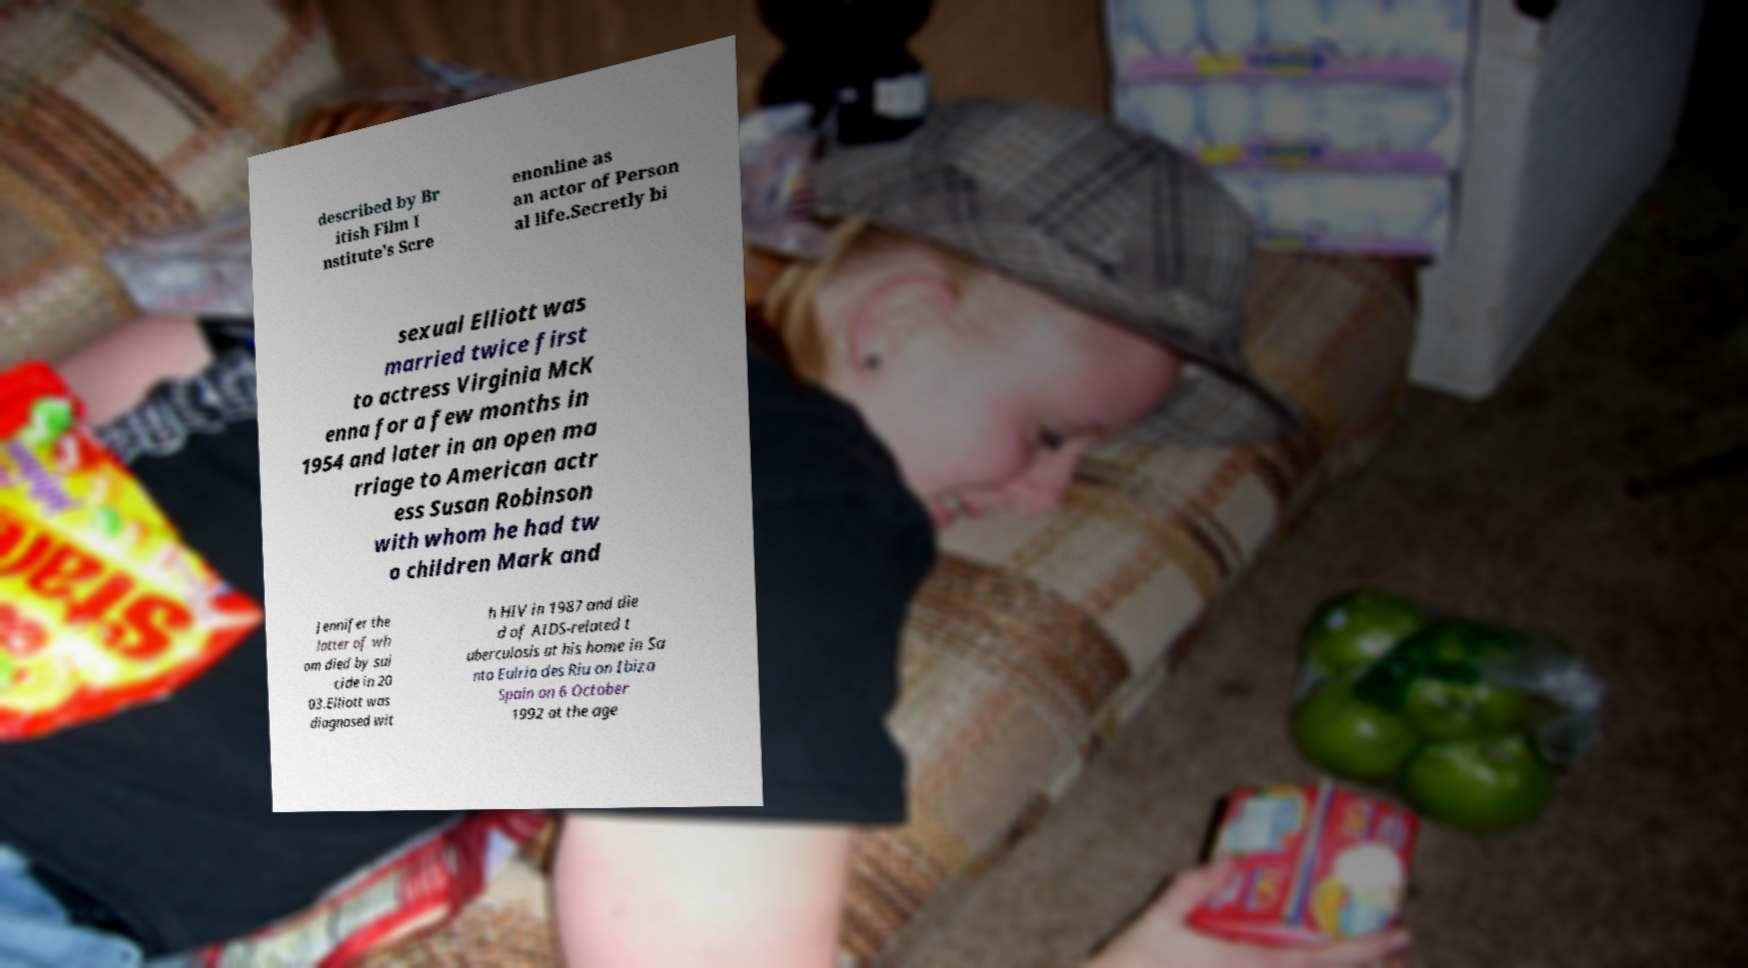Can you accurately transcribe the text from the provided image for me? described by Br itish Film I nstitute's Scre enonline as an actor of Person al life.Secretly bi sexual Elliott was married twice first to actress Virginia McK enna for a few months in 1954 and later in an open ma rriage to American actr ess Susan Robinson with whom he had tw o children Mark and Jennifer the latter of wh om died by sui cide in 20 03.Elliott was diagnosed wit h HIV in 1987 and die d of AIDS-related t uberculosis at his home in Sa nta Eulria des Riu on Ibiza Spain on 6 October 1992 at the age 